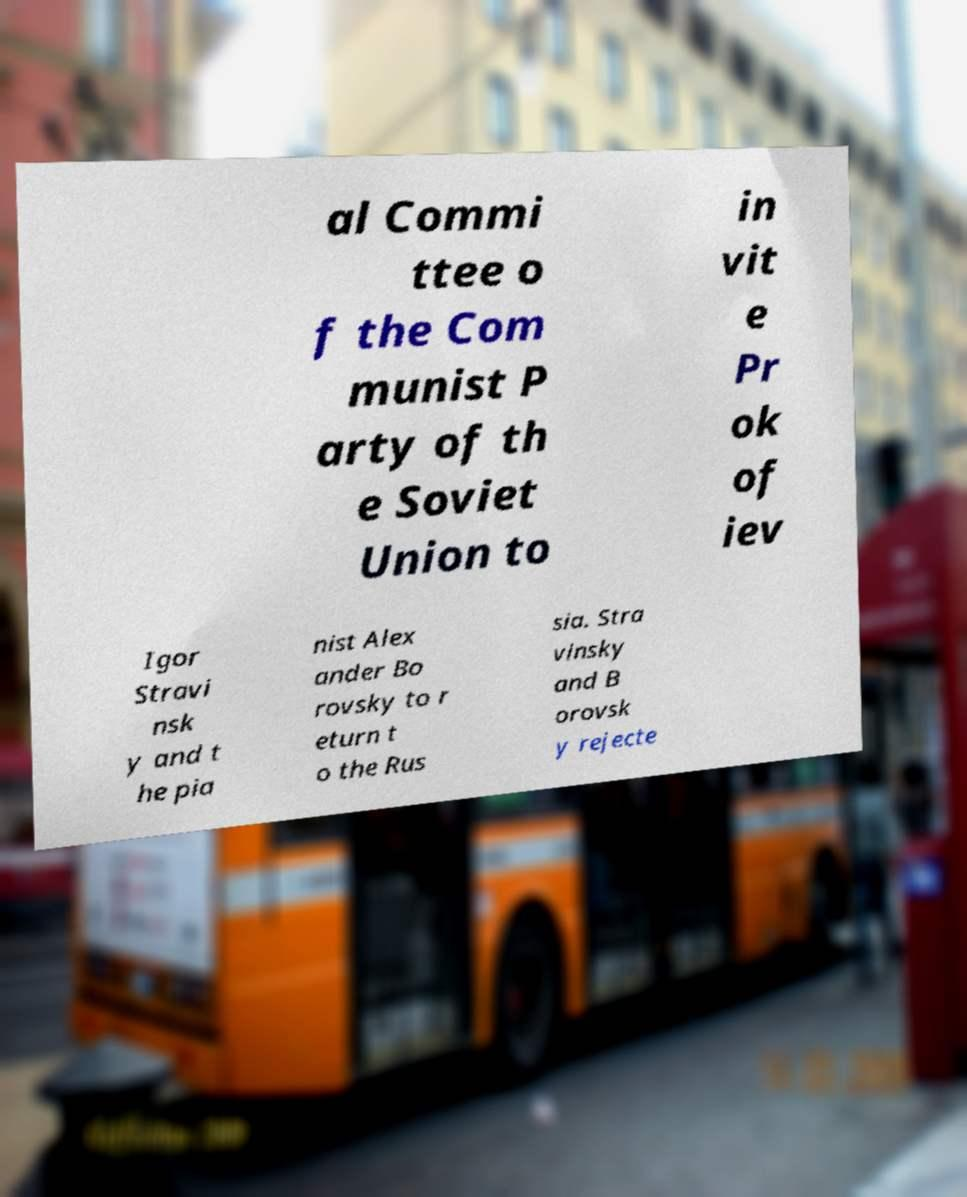I need the written content from this picture converted into text. Can you do that? al Commi ttee o f the Com munist P arty of th e Soviet Union to in vit e Pr ok of iev Igor Stravi nsk y and t he pia nist Alex ander Bo rovsky to r eturn t o the Rus sia. Stra vinsky and B orovsk y rejecte 